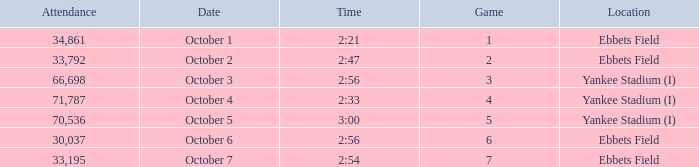Yankee stadium (i), and a time of 3:00 has what attendance for this location? 70536.0. 